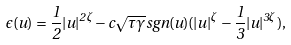Convert formula to latex. <formula><loc_0><loc_0><loc_500><loc_500>\epsilon ( u ) = \frac { 1 } { 2 } | u | ^ { 2 \zeta } - c \sqrt { \tau \gamma } s g n ( u ) ( | u | ^ { \zeta } - \frac { 1 } { 3 } | u | ^ { 3 \zeta } ) ,</formula> 